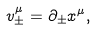<formula> <loc_0><loc_0><loc_500><loc_500>v ^ { \mu } _ { \pm } = \partial _ { \pm } x ^ { \mu } ,</formula> 